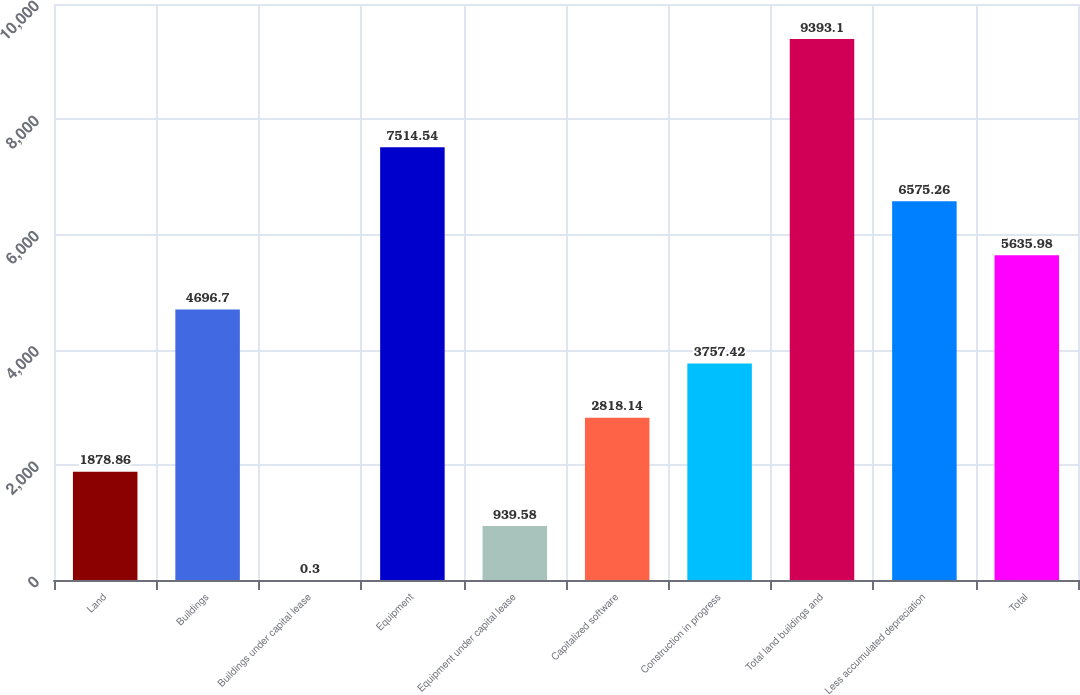Convert chart. <chart><loc_0><loc_0><loc_500><loc_500><bar_chart><fcel>Land<fcel>Buildings<fcel>Buildings under capital lease<fcel>Equipment<fcel>Equipment under capital lease<fcel>Capitalized software<fcel>Construction in progress<fcel>Total land buildings and<fcel>Less accumulated depreciation<fcel>Total<nl><fcel>1878.86<fcel>4696.7<fcel>0.3<fcel>7514.54<fcel>939.58<fcel>2818.14<fcel>3757.42<fcel>9393.1<fcel>6575.26<fcel>5635.98<nl></chart> 